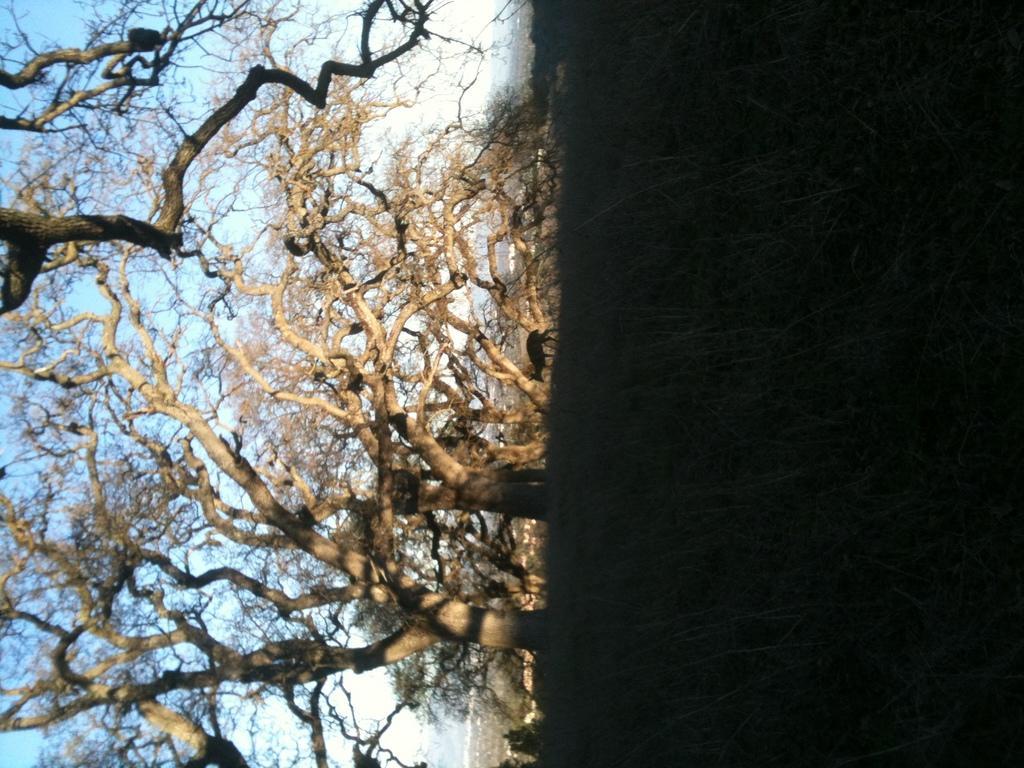Describe this image in one or two sentences. In the center of the image there is an animal. On the right there is grass. On the left there are trees. In the background there is sky. 